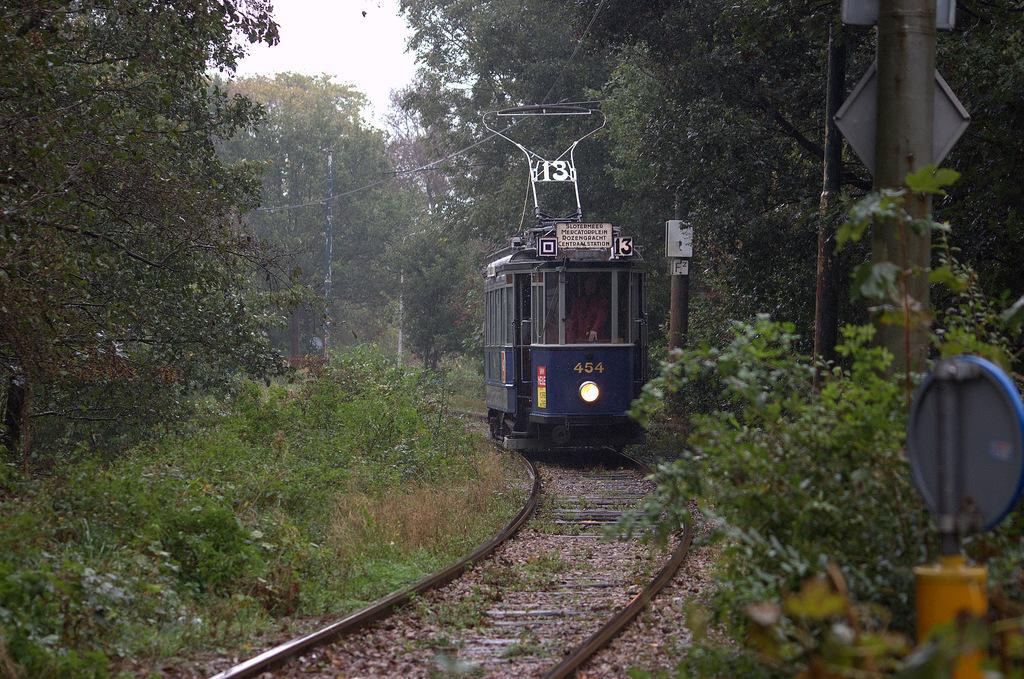How would you summarize this image in a sentence or two? In this image in the center there is a train running on railway track and there are trees, there is grass on the ground and there are poles. 